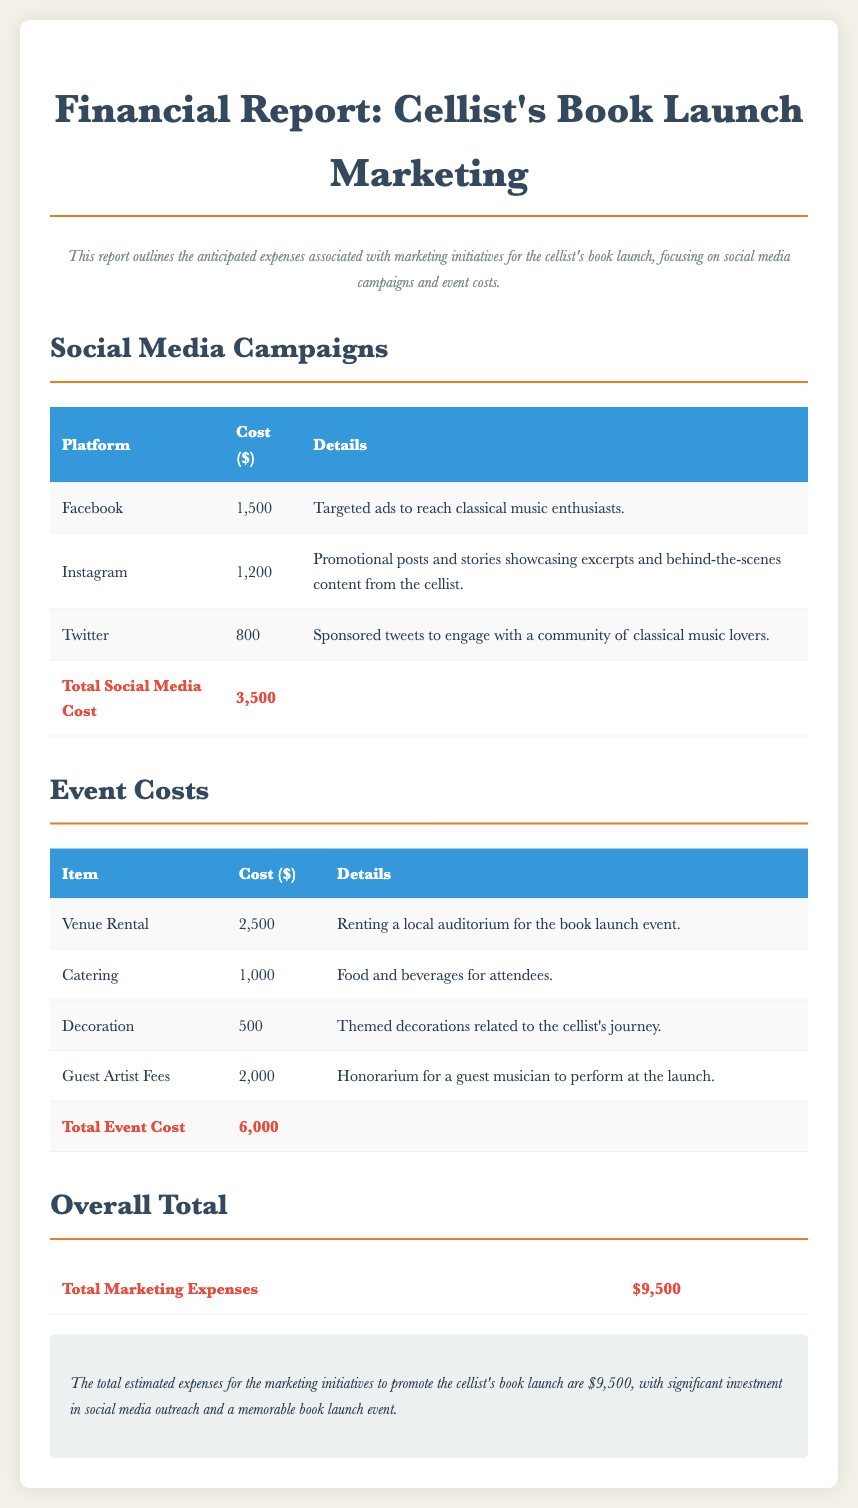What is the total social media cost? The total social media cost is summarized at the end of the social media campaigns section, which includes costs from multiple platforms.
Answer: 3,500 What is the cost for catering at the event? The catering cost is detailed in the event costs section which lists all expenses associated with the book launch event.
Answer: 1,000 How much is allocated for guest artist fees? The guest artist fees are specified in the event costs table under the corresponding item, indicating a separate allocation for this expense.
Answer: 2,000 What is the total marketing expense? The overall total marketing expenses are presented at the end of the financial report, reflecting the sum of both social media and event costs.
Answer: 9,500 What social media platform has the highest cost? By comparing the costs listed in the social media campaigns, it is clear that one specific platform incurs more expenses than the others.
Answer: Facebook What is the venue rental cost? The venue rental cost is directly provided in the event costs table, giving a precise figure for this particular expense.
Answer: 2,500 What type of report is this? The document is explicitly described in the title and introductory section, clarifying the nature of its content related to financial expenses.
Answer: Financial Report What is included in the social media campaigns? The social media campaigns section details the platforms used and their associated costs along with specific purposes for each platform.
Answer: Facebook, Instagram, Twitter How much is spent on decorations for the event? The decorations cost is mentioned in the event costs table, detailing the price for themed decor at the book launch.
Answer: 500 